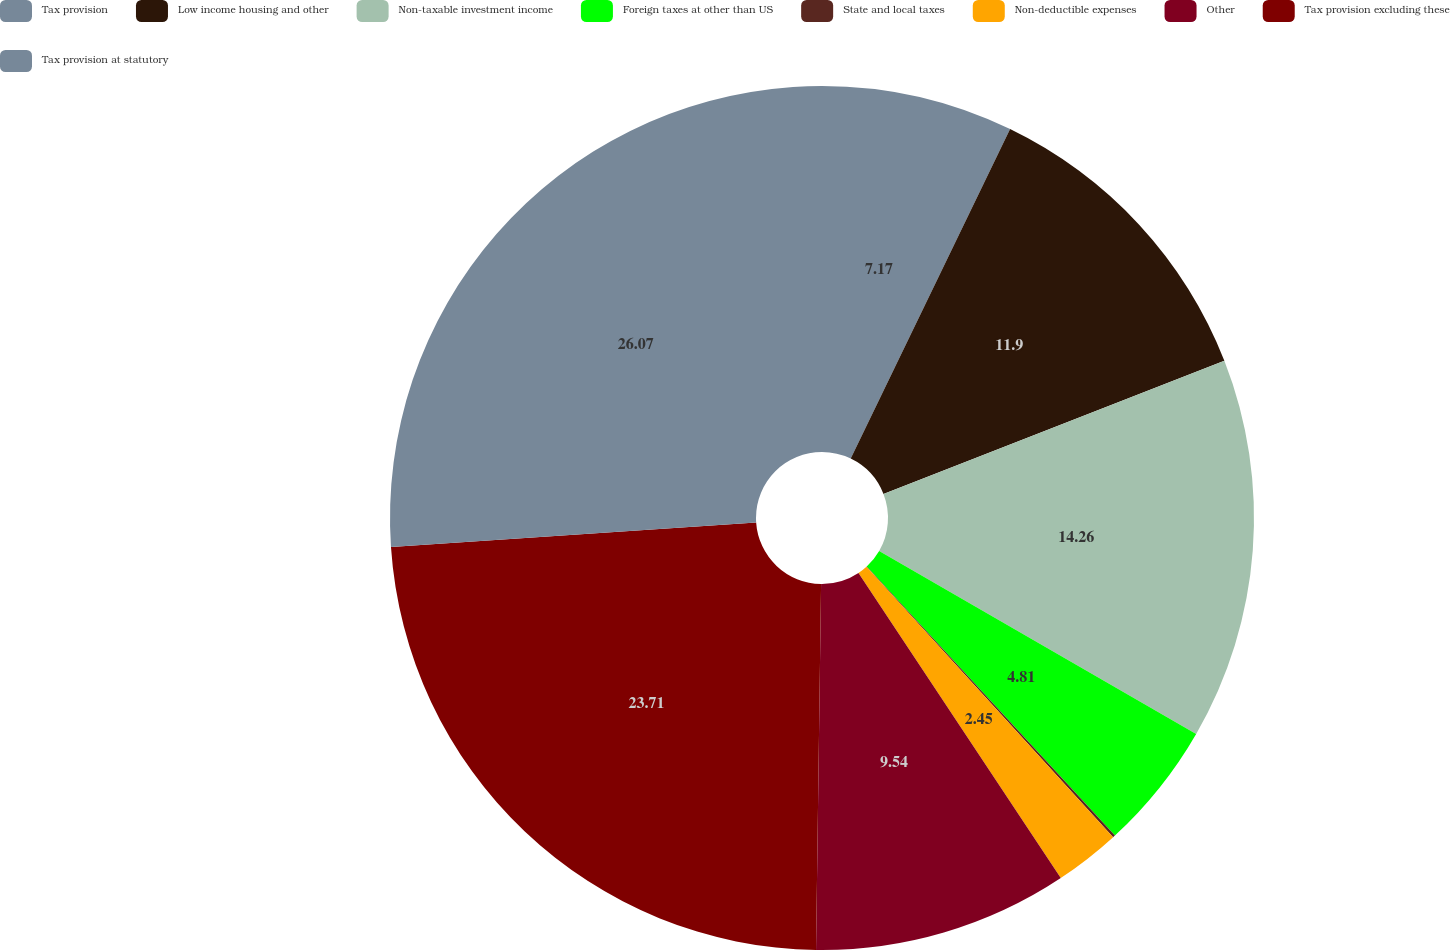Convert chart to OTSL. <chart><loc_0><loc_0><loc_500><loc_500><pie_chart><fcel>Tax provision<fcel>Low income housing and other<fcel>Non-taxable investment income<fcel>Foreign taxes at other than US<fcel>State and local taxes<fcel>Non-deductible expenses<fcel>Other<fcel>Tax provision excluding these<fcel>Tax provision at statutory<nl><fcel>7.17%<fcel>11.9%<fcel>14.26%<fcel>4.81%<fcel>0.09%<fcel>2.45%<fcel>9.54%<fcel>23.71%<fcel>26.07%<nl></chart> 